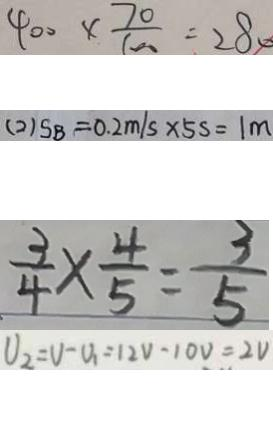Convert formula to latex. <formula><loc_0><loc_0><loc_500><loc_500>4 0 0 \times \frac { 7 0 } { 1 0 0 } = 2 8 0 
 ( 2 ) S B = 0 . 2 m / s \times 5 s = 1 m 
 \frac { 3 } { 4 } \times \frac { 4 } { 5 } = \frac { 3 } { 5 } 
 U _ { 2 } = V - U _ { 1 } = 1 2 V - 1 0 V = 2 V</formula> 